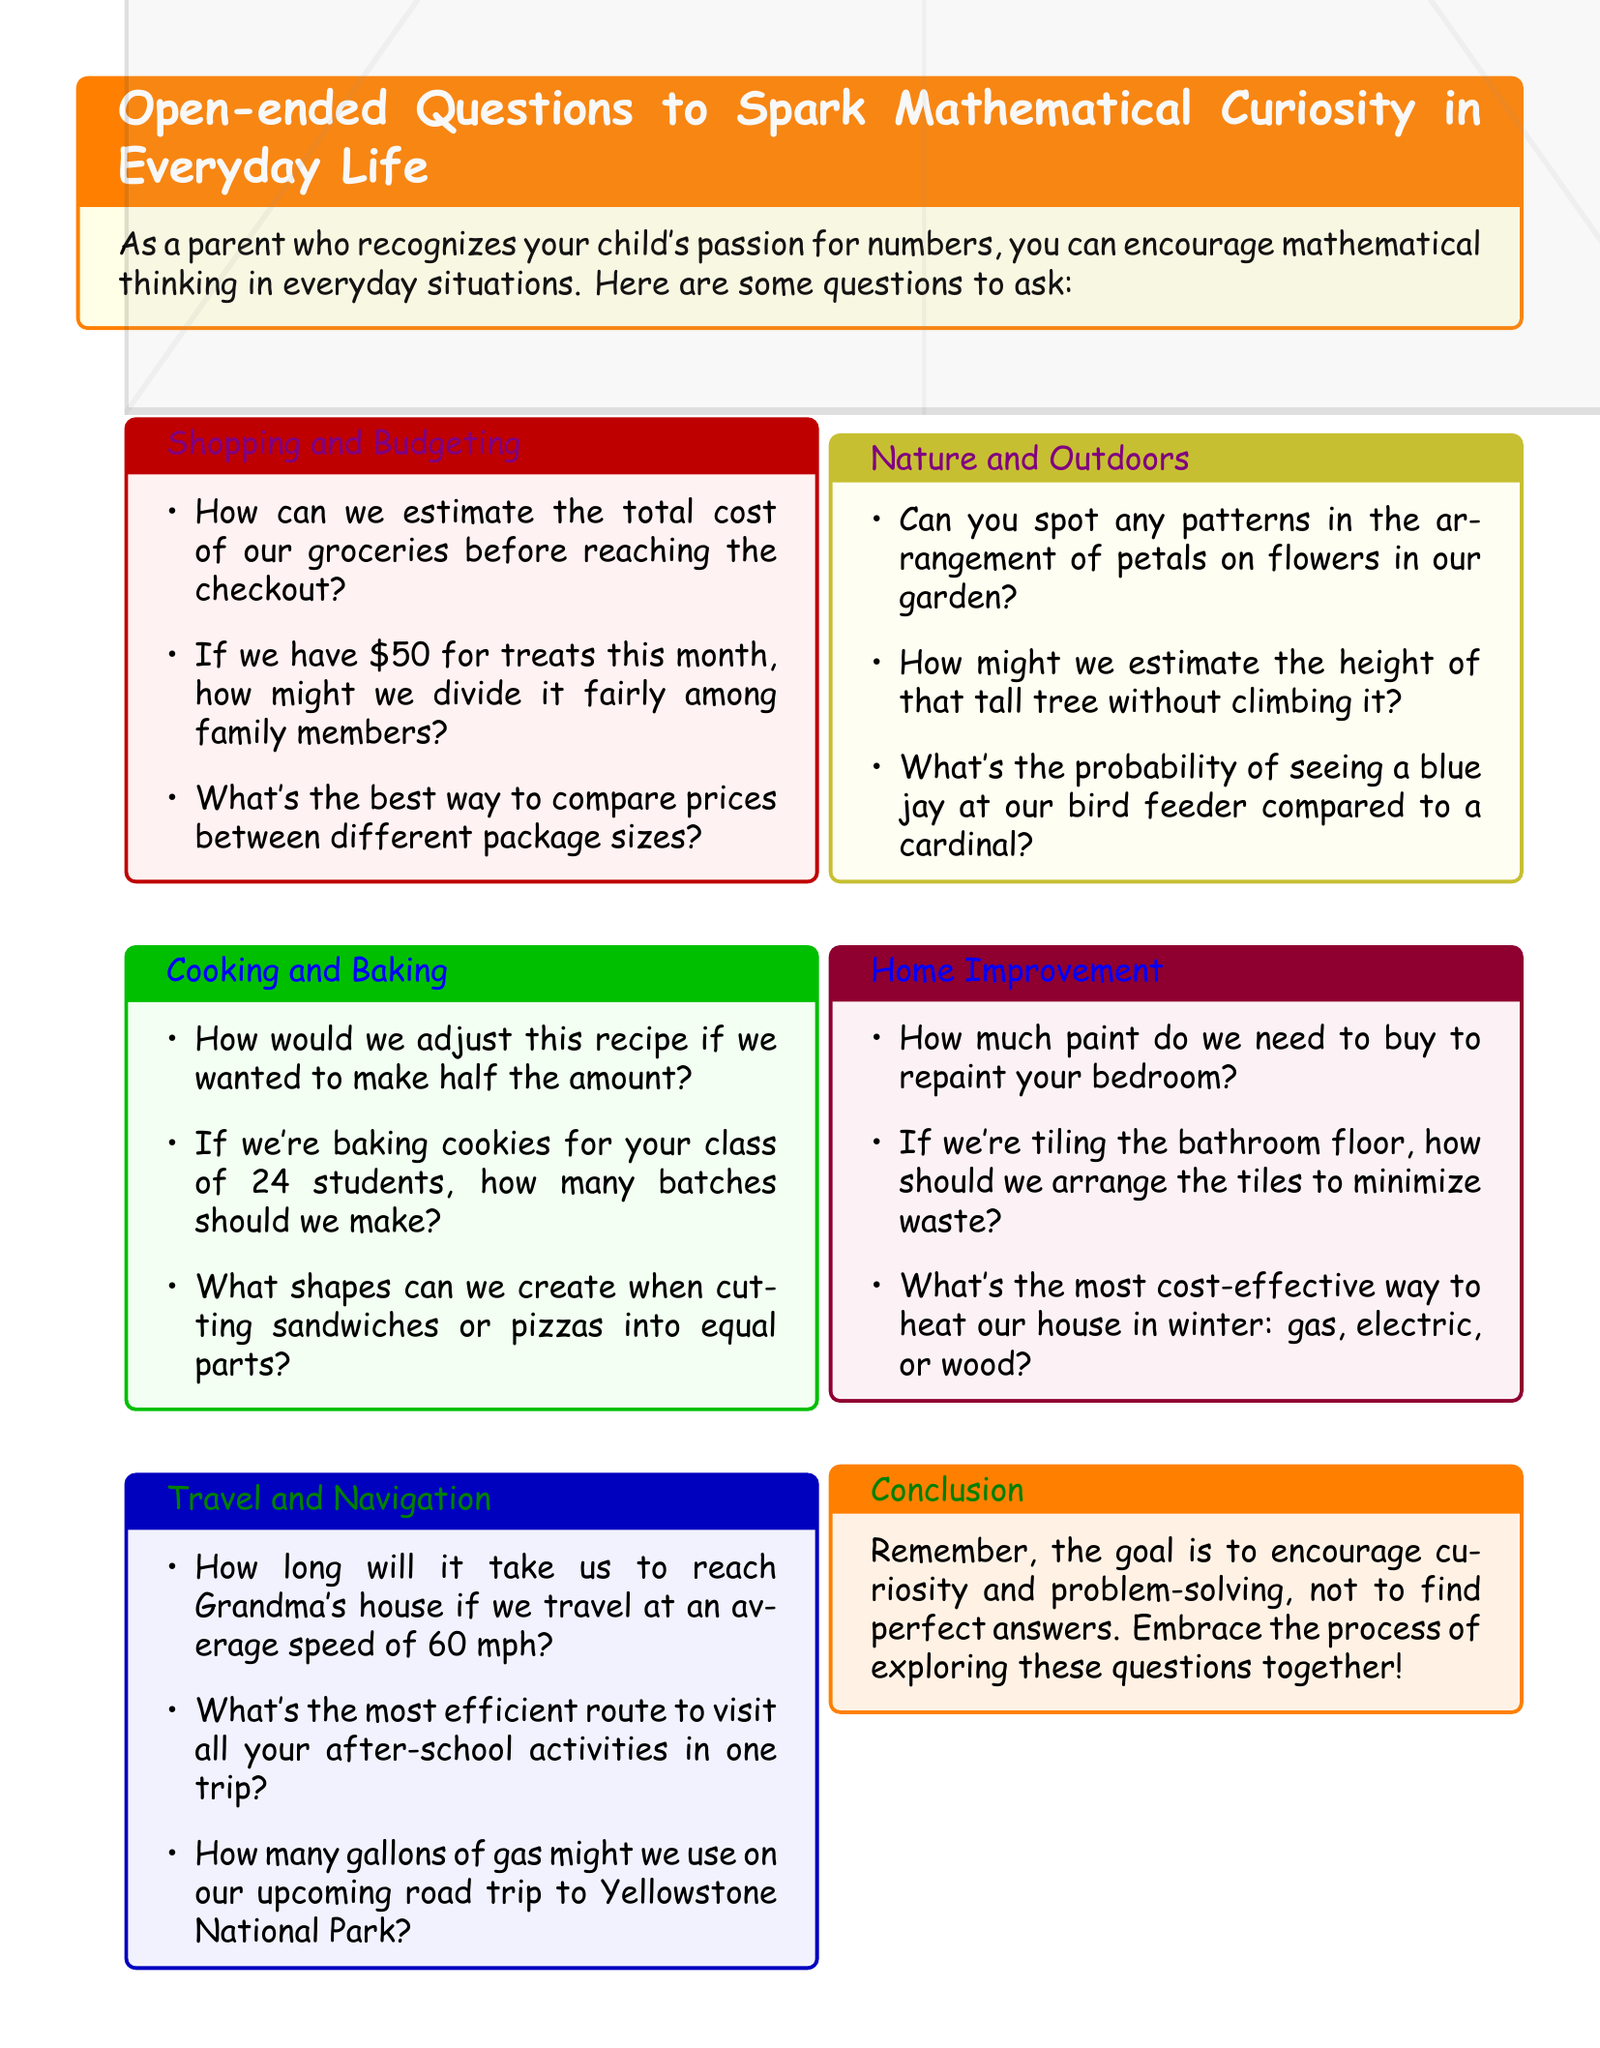How many sections are in the document? The document contains several sections, each dedicated to different themes including Shopping and Budgeting, Cooking and Baking, Travel and Navigation, Nature and Outdoors, and Home Improvement.
Answer: 5 What is the purpose of the questions listed? The introduction explains that the purpose of the questions is to encourage mathematical thinking and curiosity in everyday life through various scenarios.
Answer: Encourage mathematical thinking What is one of the questions under the Cooking and Baking section? The Cooking and Baking section has multiple questions; one asks about adjusting a recipe to make half the amount, highlighting a practical culinary scenario.
Answer: How would we adjust this recipe if we wanted to make half the amount? What color is the box for the Home Improvement section? The Home Improvement section uses a specific color to distinguish it; the box color is purple as outlined within the document's formatting.
Answer: Purple What topic is addressed in the Nature and Outdoors section? This section includes questions that relate to observing nature, such as spotting patterns in flower petals, which encourages exploration of mathematical concepts in natural settings.
Answer: Spotting patterns in flower petals What does the conclusion emphasize? The conclusion highlights the importance of allowing for exploration and not focusing solely on finding perfect answers, reflecting a philosophy of learning.
Answer: Encourage curiosity and problem-solving Who is the document intended for? The content of the document clearly points towards parents who want to engage with their children about mathematics in everyday situations, making it specifically relevant for them.
Answer: Parents 